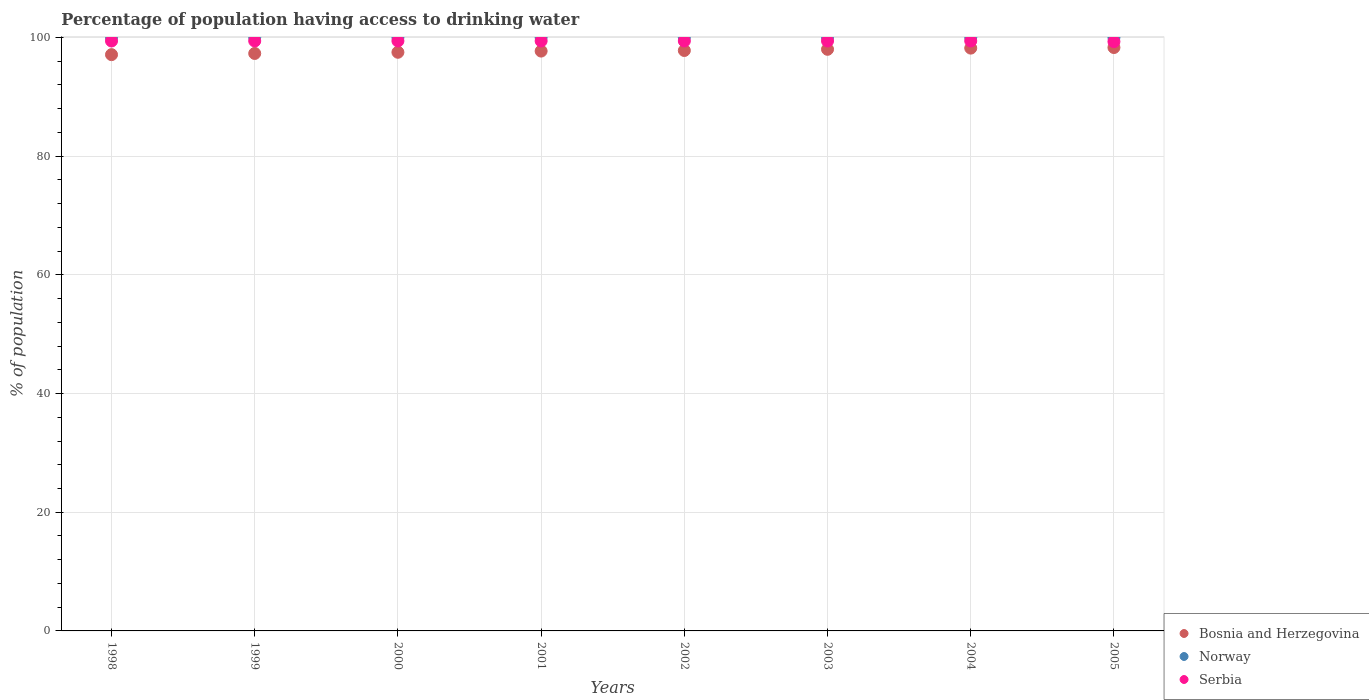Is the number of dotlines equal to the number of legend labels?
Give a very brief answer. Yes. What is the percentage of population having access to drinking water in Bosnia and Herzegovina in 2002?
Your answer should be compact. 97.8. Across all years, what is the maximum percentage of population having access to drinking water in Norway?
Keep it short and to the point. 100. Across all years, what is the minimum percentage of population having access to drinking water in Bosnia and Herzegovina?
Ensure brevity in your answer.  97.1. In which year was the percentage of population having access to drinking water in Bosnia and Herzegovina minimum?
Ensure brevity in your answer.  1998. What is the total percentage of population having access to drinking water in Norway in the graph?
Ensure brevity in your answer.  800. What is the difference between the percentage of population having access to drinking water in Norway in 1999 and that in 2003?
Your answer should be very brief. 0. What is the difference between the percentage of population having access to drinking water in Serbia in 2004 and the percentage of population having access to drinking water in Bosnia and Herzegovina in 2001?
Ensure brevity in your answer.  1.7. In the year 2004, what is the difference between the percentage of population having access to drinking water in Norway and percentage of population having access to drinking water in Bosnia and Herzegovina?
Ensure brevity in your answer.  1.8. What is the ratio of the percentage of population having access to drinking water in Bosnia and Herzegovina in 1999 to that in 2001?
Offer a very short reply. 1. Is the difference between the percentage of population having access to drinking water in Norway in 2002 and 2003 greater than the difference between the percentage of population having access to drinking water in Bosnia and Herzegovina in 2002 and 2003?
Ensure brevity in your answer.  Yes. What is the difference between the highest and the second highest percentage of population having access to drinking water in Bosnia and Herzegovina?
Provide a succinct answer. 0.1. What is the difference between the highest and the lowest percentage of population having access to drinking water in Norway?
Give a very brief answer. 0. Is the sum of the percentage of population having access to drinking water in Serbia in 1998 and 2003 greater than the maximum percentage of population having access to drinking water in Bosnia and Herzegovina across all years?
Offer a terse response. Yes. Is it the case that in every year, the sum of the percentage of population having access to drinking water in Norway and percentage of population having access to drinking water in Bosnia and Herzegovina  is greater than the percentage of population having access to drinking water in Serbia?
Offer a terse response. Yes. Is the percentage of population having access to drinking water in Norway strictly greater than the percentage of population having access to drinking water in Serbia over the years?
Provide a succinct answer. Yes. Is the percentage of population having access to drinking water in Norway strictly less than the percentage of population having access to drinking water in Bosnia and Herzegovina over the years?
Give a very brief answer. No. How many years are there in the graph?
Give a very brief answer. 8. Are the values on the major ticks of Y-axis written in scientific E-notation?
Your answer should be compact. No. How many legend labels are there?
Provide a short and direct response. 3. What is the title of the graph?
Provide a succinct answer. Percentage of population having access to drinking water. Does "Korea (Democratic)" appear as one of the legend labels in the graph?
Your answer should be very brief. No. What is the label or title of the Y-axis?
Give a very brief answer. % of population. What is the % of population in Bosnia and Herzegovina in 1998?
Provide a short and direct response. 97.1. What is the % of population in Serbia in 1998?
Offer a terse response. 99.4. What is the % of population of Bosnia and Herzegovina in 1999?
Keep it short and to the point. 97.3. What is the % of population of Norway in 1999?
Keep it short and to the point. 100. What is the % of population of Serbia in 1999?
Make the answer very short. 99.4. What is the % of population in Bosnia and Herzegovina in 2000?
Your response must be concise. 97.5. What is the % of population in Serbia in 2000?
Offer a terse response. 99.4. What is the % of population of Bosnia and Herzegovina in 2001?
Offer a terse response. 97.7. What is the % of population of Serbia in 2001?
Provide a succinct answer. 99.4. What is the % of population of Bosnia and Herzegovina in 2002?
Keep it short and to the point. 97.8. What is the % of population of Norway in 2002?
Offer a very short reply. 100. What is the % of population in Serbia in 2002?
Your response must be concise. 99.4. What is the % of population of Norway in 2003?
Provide a short and direct response. 100. What is the % of population in Serbia in 2003?
Offer a very short reply. 99.4. What is the % of population in Bosnia and Herzegovina in 2004?
Give a very brief answer. 98.2. What is the % of population in Norway in 2004?
Keep it short and to the point. 100. What is the % of population of Serbia in 2004?
Your answer should be very brief. 99.4. What is the % of population in Bosnia and Herzegovina in 2005?
Make the answer very short. 98.3. What is the % of population in Serbia in 2005?
Offer a very short reply. 99.3. Across all years, what is the maximum % of population in Bosnia and Herzegovina?
Make the answer very short. 98.3. Across all years, what is the maximum % of population in Serbia?
Make the answer very short. 99.4. Across all years, what is the minimum % of population in Bosnia and Herzegovina?
Keep it short and to the point. 97.1. Across all years, what is the minimum % of population in Serbia?
Your answer should be compact. 99.3. What is the total % of population in Bosnia and Herzegovina in the graph?
Your answer should be compact. 781.9. What is the total % of population of Norway in the graph?
Provide a short and direct response. 800. What is the total % of population in Serbia in the graph?
Your answer should be very brief. 795.1. What is the difference between the % of population in Bosnia and Herzegovina in 1998 and that in 2000?
Your response must be concise. -0.4. What is the difference between the % of population in Norway in 1998 and that in 2000?
Make the answer very short. 0. What is the difference between the % of population in Serbia in 1998 and that in 2000?
Provide a succinct answer. 0. What is the difference between the % of population of Bosnia and Herzegovina in 1998 and that in 2001?
Make the answer very short. -0.6. What is the difference between the % of population of Norway in 1998 and that in 2001?
Keep it short and to the point. 0. What is the difference between the % of population in Serbia in 1998 and that in 2001?
Offer a terse response. 0. What is the difference between the % of population of Bosnia and Herzegovina in 1998 and that in 2002?
Offer a terse response. -0.7. What is the difference between the % of population in Bosnia and Herzegovina in 1998 and that in 2003?
Keep it short and to the point. -0.9. What is the difference between the % of population in Bosnia and Herzegovina in 1998 and that in 2004?
Provide a succinct answer. -1.1. What is the difference between the % of population of Norway in 1998 and that in 2004?
Your answer should be very brief. 0. What is the difference between the % of population in Bosnia and Herzegovina in 1998 and that in 2005?
Give a very brief answer. -1.2. What is the difference between the % of population of Bosnia and Herzegovina in 1999 and that in 2000?
Your response must be concise. -0.2. What is the difference between the % of population of Bosnia and Herzegovina in 1999 and that in 2001?
Give a very brief answer. -0.4. What is the difference between the % of population of Bosnia and Herzegovina in 1999 and that in 2002?
Your answer should be very brief. -0.5. What is the difference between the % of population of Serbia in 1999 and that in 2002?
Provide a short and direct response. 0. What is the difference between the % of population in Bosnia and Herzegovina in 1999 and that in 2003?
Offer a very short reply. -0.7. What is the difference between the % of population of Bosnia and Herzegovina in 1999 and that in 2004?
Give a very brief answer. -0.9. What is the difference between the % of population of Norway in 1999 and that in 2004?
Keep it short and to the point. 0. What is the difference between the % of population in Norway in 1999 and that in 2005?
Give a very brief answer. 0. What is the difference between the % of population of Serbia in 2000 and that in 2001?
Give a very brief answer. 0. What is the difference between the % of population of Serbia in 2000 and that in 2002?
Your answer should be compact. 0. What is the difference between the % of population in Serbia in 2000 and that in 2003?
Give a very brief answer. 0. What is the difference between the % of population of Serbia in 2000 and that in 2004?
Ensure brevity in your answer.  0. What is the difference between the % of population in Norway in 2000 and that in 2005?
Offer a very short reply. 0. What is the difference between the % of population in Serbia in 2000 and that in 2005?
Keep it short and to the point. 0.1. What is the difference between the % of population of Norway in 2001 and that in 2002?
Ensure brevity in your answer.  0. What is the difference between the % of population of Serbia in 2001 and that in 2002?
Your response must be concise. 0. What is the difference between the % of population of Bosnia and Herzegovina in 2001 and that in 2003?
Ensure brevity in your answer.  -0.3. What is the difference between the % of population of Serbia in 2001 and that in 2004?
Offer a very short reply. 0. What is the difference between the % of population in Norway in 2001 and that in 2005?
Offer a very short reply. 0. What is the difference between the % of population in Serbia in 2002 and that in 2003?
Your answer should be very brief. 0. What is the difference between the % of population of Bosnia and Herzegovina in 2002 and that in 2004?
Your answer should be compact. -0.4. What is the difference between the % of population in Serbia in 2002 and that in 2004?
Ensure brevity in your answer.  0. What is the difference between the % of population of Bosnia and Herzegovina in 2002 and that in 2005?
Provide a short and direct response. -0.5. What is the difference between the % of population in Bosnia and Herzegovina in 2003 and that in 2004?
Keep it short and to the point. -0.2. What is the difference between the % of population in Norway in 2003 and that in 2004?
Your response must be concise. 0. What is the difference between the % of population in Serbia in 2003 and that in 2004?
Your answer should be very brief. 0. What is the difference between the % of population of Bosnia and Herzegovina in 2003 and that in 2005?
Ensure brevity in your answer.  -0.3. What is the difference between the % of population in Norway in 2003 and that in 2005?
Keep it short and to the point. 0. What is the difference between the % of population in Serbia in 2003 and that in 2005?
Your answer should be very brief. 0.1. What is the difference between the % of population of Bosnia and Herzegovina in 2004 and that in 2005?
Make the answer very short. -0.1. What is the difference between the % of population in Norway in 2004 and that in 2005?
Give a very brief answer. 0. What is the difference between the % of population in Serbia in 2004 and that in 2005?
Offer a terse response. 0.1. What is the difference between the % of population in Bosnia and Herzegovina in 1998 and the % of population in Norway in 1999?
Provide a short and direct response. -2.9. What is the difference between the % of population in Bosnia and Herzegovina in 1998 and the % of population in Serbia in 1999?
Provide a succinct answer. -2.3. What is the difference between the % of population of Norway in 1998 and the % of population of Serbia in 1999?
Keep it short and to the point. 0.6. What is the difference between the % of population in Norway in 1998 and the % of population in Serbia in 2000?
Your answer should be very brief. 0.6. What is the difference between the % of population of Bosnia and Herzegovina in 1998 and the % of population of Norway in 2001?
Provide a succinct answer. -2.9. What is the difference between the % of population of Bosnia and Herzegovina in 1998 and the % of population of Serbia in 2003?
Offer a terse response. -2.3. What is the difference between the % of population in Norway in 1998 and the % of population in Serbia in 2003?
Offer a terse response. 0.6. What is the difference between the % of population of Bosnia and Herzegovina in 1998 and the % of population of Norway in 2004?
Offer a very short reply. -2.9. What is the difference between the % of population of Bosnia and Herzegovina in 1998 and the % of population of Serbia in 2004?
Your response must be concise. -2.3. What is the difference between the % of population in Norway in 1998 and the % of population in Serbia in 2004?
Your response must be concise. 0.6. What is the difference between the % of population of Bosnia and Herzegovina in 1998 and the % of population of Serbia in 2005?
Keep it short and to the point. -2.2. What is the difference between the % of population in Norway in 1998 and the % of population in Serbia in 2005?
Your answer should be compact. 0.7. What is the difference between the % of population in Bosnia and Herzegovina in 1999 and the % of population in Norway in 2000?
Offer a terse response. -2.7. What is the difference between the % of population in Bosnia and Herzegovina in 1999 and the % of population in Serbia in 2000?
Keep it short and to the point. -2.1. What is the difference between the % of population of Norway in 1999 and the % of population of Serbia in 2000?
Your answer should be very brief. 0.6. What is the difference between the % of population in Bosnia and Herzegovina in 1999 and the % of population in Serbia in 2001?
Your response must be concise. -2.1. What is the difference between the % of population in Norway in 1999 and the % of population in Serbia in 2002?
Your response must be concise. 0.6. What is the difference between the % of population in Norway in 1999 and the % of population in Serbia in 2003?
Offer a very short reply. 0.6. What is the difference between the % of population in Bosnia and Herzegovina in 1999 and the % of population in Norway in 2004?
Give a very brief answer. -2.7. What is the difference between the % of population of Norway in 1999 and the % of population of Serbia in 2004?
Your response must be concise. 0.6. What is the difference between the % of population of Bosnia and Herzegovina in 1999 and the % of population of Norway in 2005?
Offer a very short reply. -2.7. What is the difference between the % of population of Bosnia and Herzegovina in 2000 and the % of population of Serbia in 2001?
Make the answer very short. -1.9. What is the difference between the % of population in Bosnia and Herzegovina in 2000 and the % of population in Serbia in 2002?
Your response must be concise. -1.9. What is the difference between the % of population in Norway in 2000 and the % of population in Serbia in 2002?
Ensure brevity in your answer.  0.6. What is the difference between the % of population of Bosnia and Herzegovina in 2000 and the % of population of Serbia in 2003?
Provide a short and direct response. -1.9. What is the difference between the % of population of Norway in 2000 and the % of population of Serbia in 2003?
Provide a succinct answer. 0.6. What is the difference between the % of population in Bosnia and Herzegovina in 2000 and the % of population in Serbia in 2004?
Offer a terse response. -1.9. What is the difference between the % of population in Norway in 2000 and the % of population in Serbia in 2004?
Your response must be concise. 0.6. What is the difference between the % of population of Bosnia and Herzegovina in 2000 and the % of population of Norway in 2005?
Offer a terse response. -2.5. What is the difference between the % of population of Bosnia and Herzegovina in 2001 and the % of population of Serbia in 2002?
Make the answer very short. -1.7. What is the difference between the % of population of Bosnia and Herzegovina in 2001 and the % of population of Norway in 2003?
Offer a terse response. -2.3. What is the difference between the % of population of Bosnia and Herzegovina in 2001 and the % of population of Serbia in 2003?
Offer a terse response. -1.7. What is the difference between the % of population of Norway in 2001 and the % of population of Serbia in 2003?
Provide a short and direct response. 0.6. What is the difference between the % of population of Bosnia and Herzegovina in 2001 and the % of population of Norway in 2004?
Ensure brevity in your answer.  -2.3. What is the difference between the % of population of Bosnia and Herzegovina in 2001 and the % of population of Norway in 2005?
Give a very brief answer. -2.3. What is the difference between the % of population of Norway in 2001 and the % of population of Serbia in 2005?
Give a very brief answer. 0.7. What is the difference between the % of population of Bosnia and Herzegovina in 2002 and the % of population of Serbia in 2003?
Offer a terse response. -1.6. What is the difference between the % of population of Bosnia and Herzegovina in 2002 and the % of population of Norway in 2004?
Keep it short and to the point. -2.2. What is the difference between the % of population in Bosnia and Herzegovina in 2002 and the % of population in Serbia in 2005?
Your response must be concise. -1.5. What is the difference between the % of population of Bosnia and Herzegovina in 2003 and the % of population of Serbia in 2004?
Your answer should be compact. -1.4. What is the difference between the % of population of Norway in 2003 and the % of population of Serbia in 2004?
Your answer should be compact. 0.6. What is the difference between the % of population in Bosnia and Herzegovina in 2003 and the % of population in Norway in 2005?
Your answer should be compact. -2. What is the average % of population in Bosnia and Herzegovina per year?
Offer a very short reply. 97.74. What is the average % of population in Serbia per year?
Make the answer very short. 99.39. In the year 1998, what is the difference between the % of population of Bosnia and Herzegovina and % of population of Serbia?
Your answer should be compact. -2.3. In the year 1999, what is the difference between the % of population of Bosnia and Herzegovina and % of population of Serbia?
Your answer should be very brief. -2.1. In the year 1999, what is the difference between the % of population in Norway and % of population in Serbia?
Offer a terse response. 0.6. In the year 2000, what is the difference between the % of population of Bosnia and Herzegovina and % of population of Serbia?
Provide a short and direct response. -1.9. In the year 2000, what is the difference between the % of population in Norway and % of population in Serbia?
Offer a very short reply. 0.6. In the year 2002, what is the difference between the % of population of Norway and % of population of Serbia?
Keep it short and to the point. 0.6. In the year 2003, what is the difference between the % of population in Bosnia and Herzegovina and % of population in Norway?
Your answer should be compact. -2. In the year 2003, what is the difference between the % of population of Bosnia and Herzegovina and % of population of Serbia?
Give a very brief answer. -1.4. In the year 2004, what is the difference between the % of population in Bosnia and Herzegovina and % of population in Norway?
Keep it short and to the point. -1.8. In the year 2004, what is the difference between the % of population of Bosnia and Herzegovina and % of population of Serbia?
Your answer should be very brief. -1.2. In the year 2004, what is the difference between the % of population of Norway and % of population of Serbia?
Provide a succinct answer. 0.6. In the year 2005, what is the difference between the % of population in Bosnia and Herzegovina and % of population in Norway?
Keep it short and to the point. -1.7. What is the ratio of the % of population in Bosnia and Herzegovina in 1998 to that in 1999?
Ensure brevity in your answer.  1. What is the ratio of the % of population in Norway in 1998 to that in 1999?
Give a very brief answer. 1. What is the ratio of the % of population in Serbia in 1998 to that in 1999?
Give a very brief answer. 1. What is the ratio of the % of population of Norway in 1998 to that in 2001?
Make the answer very short. 1. What is the ratio of the % of population in Bosnia and Herzegovina in 1998 to that in 2002?
Offer a very short reply. 0.99. What is the ratio of the % of population in Norway in 1998 to that in 2002?
Give a very brief answer. 1. What is the ratio of the % of population of Bosnia and Herzegovina in 1998 to that in 2003?
Your answer should be very brief. 0.99. What is the ratio of the % of population in Norway in 1998 to that in 2003?
Your answer should be compact. 1. What is the ratio of the % of population of Bosnia and Herzegovina in 1998 to that in 2004?
Offer a terse response. 0.99. What is the ratio of the % of population of Bosnia and Herzegovina in 1998 to that in 2005?
Offer a terse response. 0.99. What is the ratio of the % of population of Serbia in 1998 to that in 2005?
Offer a terse response. 1. What is the ratio of the % of population in Serbia in 1999 to that in 2001?
Your response must be concise. 1. What is the ratio of the % of population of Norway in 1999 to that in 2002?
Offer a very short reply. 1. What is the ratio of the % of population in Bosnia and Herzegovina in 1999 to that in 2003?
Offer a very short reply. 0.99. What is the ratio of the % of population of Norway in 1999 to that in 2003?
Provide a short and direct response. 1. What is the ratio of the % of population of Norway in 1999 to that in 2004?
Your answer should be very brief. 1. What is the ratio of the % of population in Bosnia and Herzegovina in 1999 to that in 2005?
Your response must be concise. 0.99. What is the ratio of the % of population of Norway in 1999 to that in 2005?
Your answer should be very brief. 1. What is the ratio of the % of population in Serbia in 1999 to that in 2005?
Give a very brief answer. 1. What is the ratio of the % of population in Bosnia and Herzegovina in 2000 to that in 2002?
Ensure brevity in your answer.  1. What is the ratio of the % of population in Norway in 2000 to that in 2002?
Give a very brief answer. 1. What is the ratio of the % of population of Serbia in 2000 to that in 2002?
Offer a terse response. 1. What is the ratio of the % of population in Bosnia and Herzegovina in 2000 to that in 2003?
Offer a very short reply. 0.99. What is the ratio of the % of population of Norway in 2000 to that in 2004?
Your answer should be compact. 1. What is the ratio of the % of population in Norway in 2000 to that in 2005?
Your answer should be compact. 1. What is the ratio of the % of population in Serbia in 2000 to that in 2005?
Provide a succinct answer. 1. What is the ratio of the % of population of Bosnia and Herzegovina in 2001 to that in 2003?
Make the answer very short. 1. What is the ratio of the % of population of Norway in 2001 to that in 2003?
Provide a succinct answer. 1. What is the ratio of the % of population in Serbia in 2001 to that in 2003?
Make the answer very short. 1. What is the ratio of the % of population of Norway in 2001 to that in 2004?
Keep it short and to the point. 1. What is the ratio of the % of population of Serbia in 2001 to that in 2004?
Provide a succinct answer. 1. What is the ratio of the % of population in Norway in 2001 to that in 2005?
Offer a terse response. 1. What is the ratio of the % of population in Serbia in 2001 to that in 2005?
Keep it short and to the point. 1. What is the ratio of the % of population of Bosnia and Herzegovina in 2002 to that in 2004?
Provide a succinct answer. 1. What is the ratio of the % of population of Norway in 2002 to that in 2004?
Offer a terse response. 1. What is the ratio of the % of population of Serbia in 2002 to that in 2005?
Keep it short and to the point. 1. What is the ratio of the % of population in Norway in 2003 to that in 2004?
Your answer should be compact. 1. What is the ratio of the % of population of Serbia in 2003 to that in 2004?
Offer a very short reply. 1. What is the ratio of the % of population of Serbia in 2003 to that in 2005?
Your answer should be compact. 1. What is the difference between the highest and the second highest % of population of Bosnia and Herzegovina?
Your answer should be very brief. 0.1. What is the difference between the highest and the second highest % of population in Serbia?
Your response must be concise. 0. What is the difference between the highest and the lowest % of population of Serbia?
Ensure brevity in your answer.  0.1. 